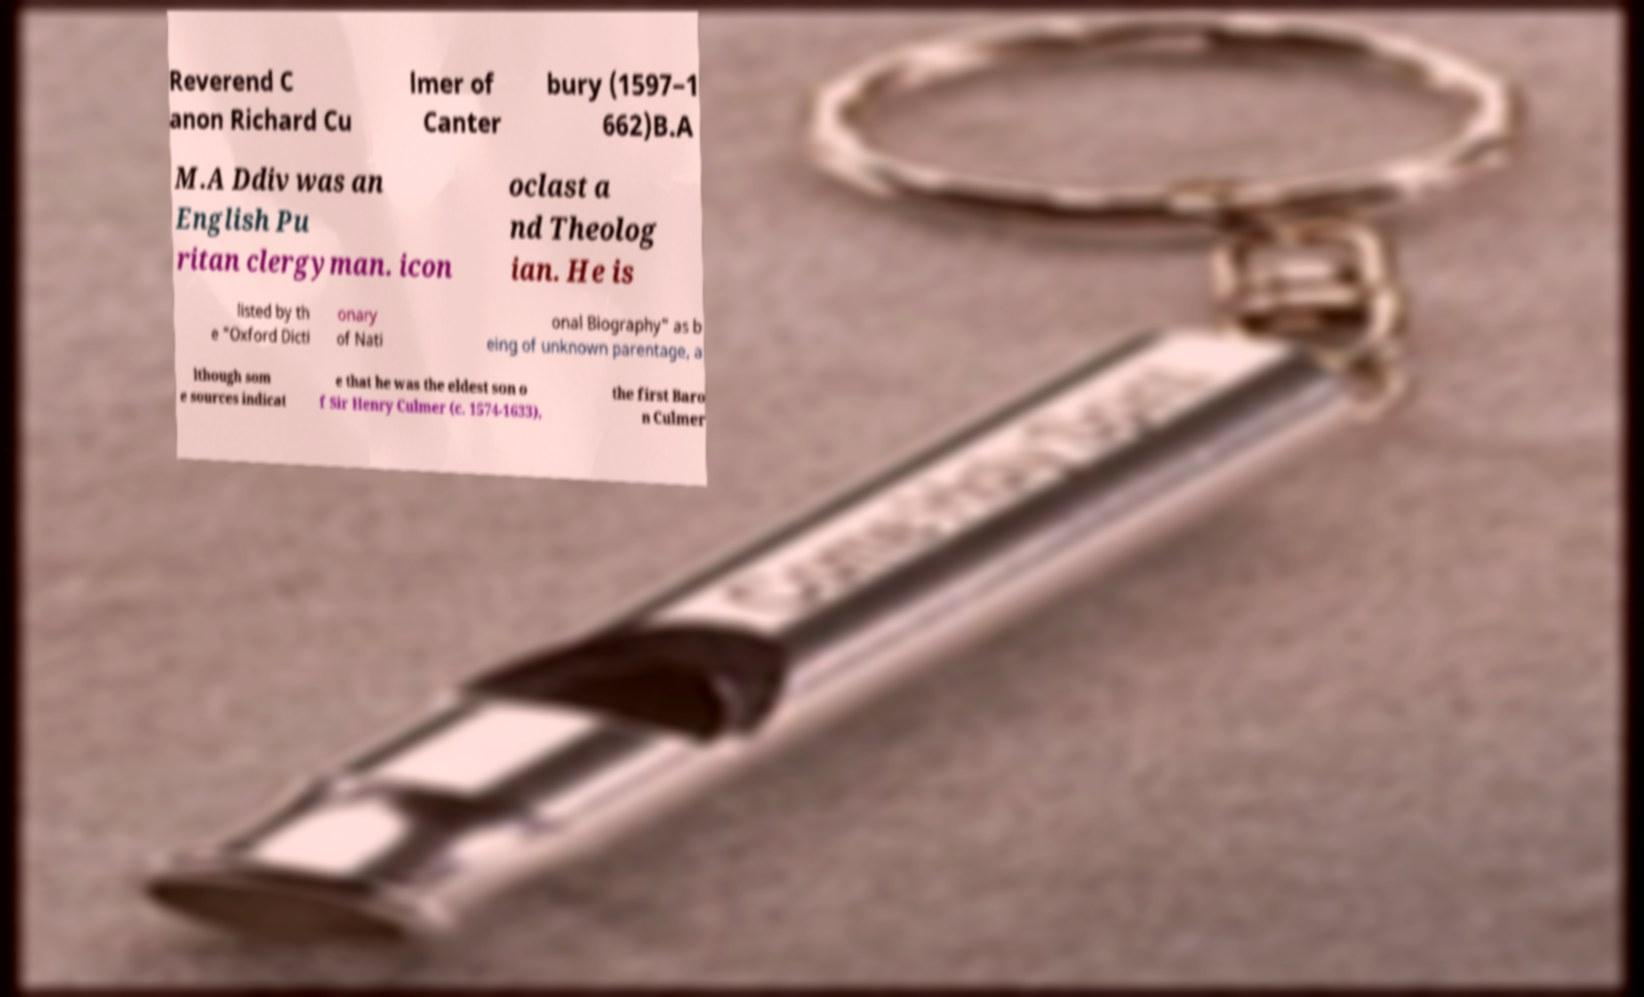Could you assist in decoding the text presented in this image and type it out clearly? Reverend C anon Richard Cu lmer of Canter bury (1597–1 662)B.A M.A Ddiv was an English Pu ritan clergyman. icon oclast a nd Theolog ian. He is listed by th e "Oxford Dicti onary of Nati onal Biography" as b eing of unknown parentage, a lthough som e sources indicat e that he was the eldest son o f Sir Henry Culmer (c. 1574-1633), the first Baro n Culmer 